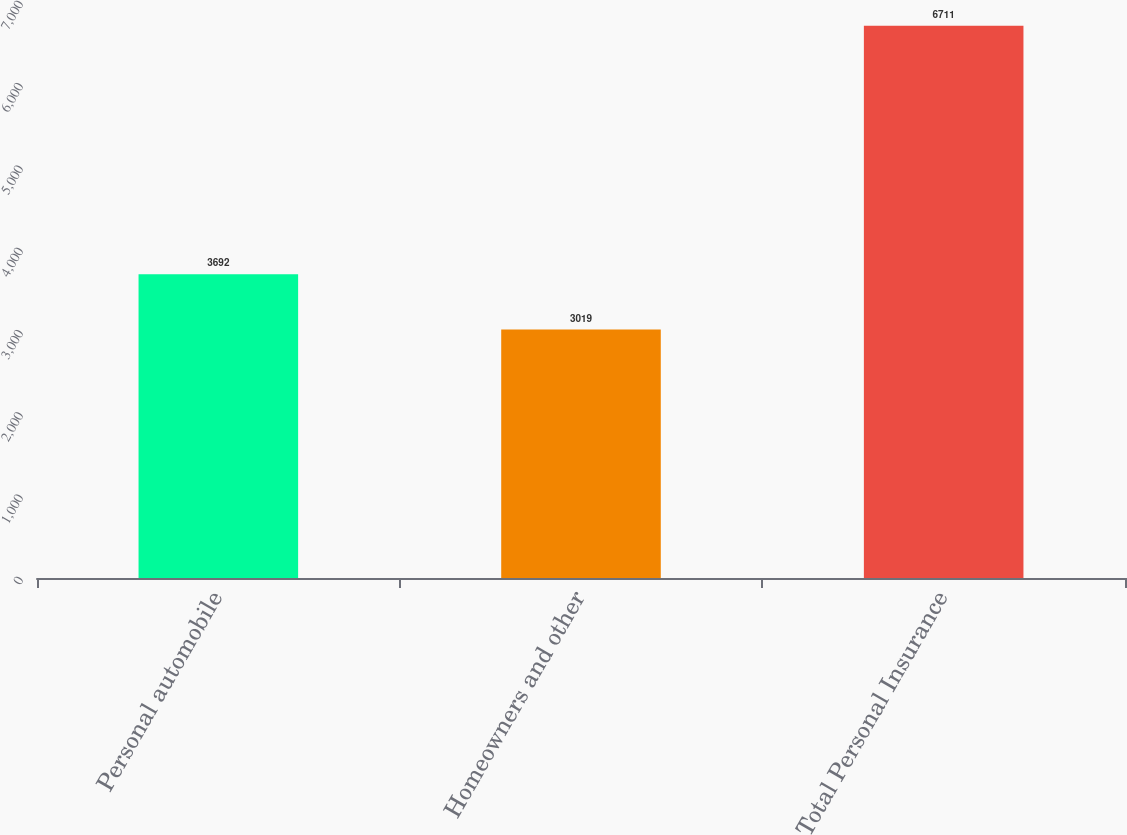Convert chart. <chart><loc_0><loc_0><loc_500><loc_500><bar_chart><fcel>Personal automobile<fcel>Homeowners and other<fcel>Total Personal Insurance<nl><fcel>3692<fcel>3019<fcel>6711<nl></chart> 